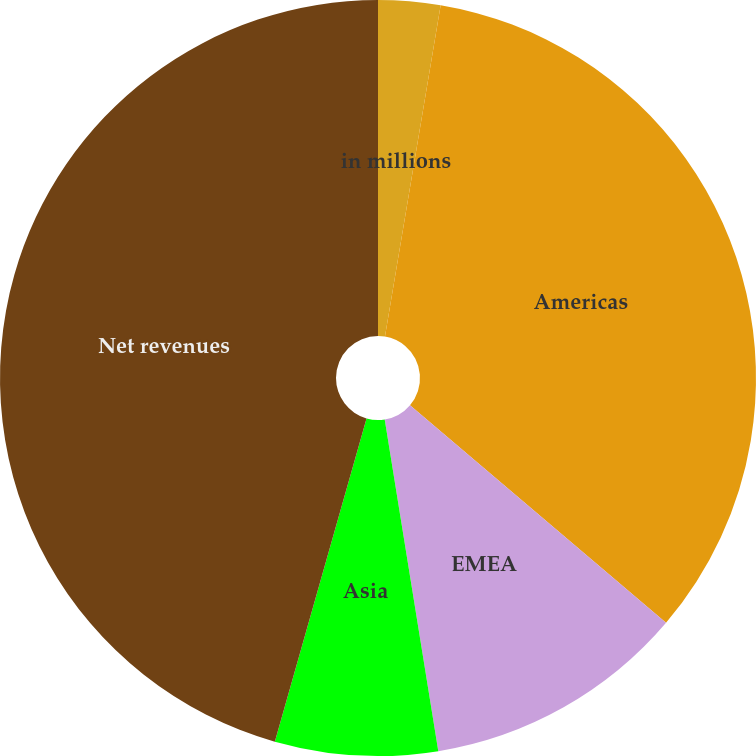Convert chart to OTSL. <chart><loc_0><loc_0><loc_500><loc_500><pie_chart><fcel>in millions<fcel>Americas<fcel>EMEA<fcel>Asia<fcel>Net revenues<nl><fcel>2.65%<fcel>33.56%<fcel>11.24%<fcel>6.95%<fcel>45.6%<nl></chart> 